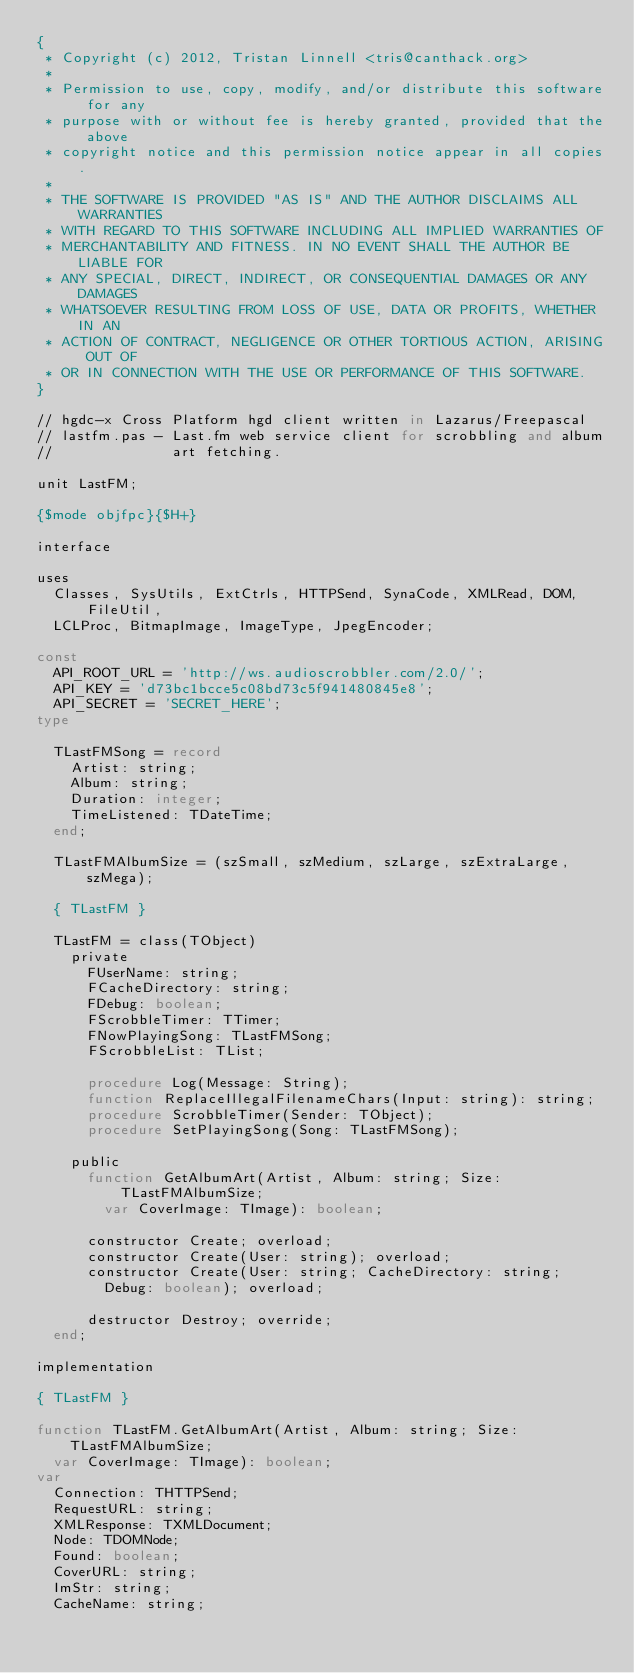<code> <loc_0><loc_0><loc_500><loc_500><_Pascal_>{
 * Copyright (c) 2012, Tristan Linnell <tris@canthack.org>
 *
 * Permission to use, copy, modify, and/or distribute this software for any
 * purpose with or without fee is hereby granted, provided that the above
 * copyright notice and this permission notice appear in all copies.
 *
 * THE SOFTWARE IS PROVIDED "AS IS" AND THE AUTHOR DISCLAIMS ALL WARRANTIES
 * WITH REGARD TO THIS SOFTWARE INCLUDING ALL IMPLIED WARRANTIES OF
 * MERCHANTABILITY AND FITNESS. IN NO EVENT SHALL THE AUTHOR BE LIABLE FOR
 * ANY SPECIAL, DIRECT, INDIRECT, OR CONSEQUENTIAL DAMAGES OR ANY DAMAGES
 * WHATSOEVER RESULTING FROM LOSS OF USE, DATA OR PROFITS, WHETHER IN AN
 * ACTION OF CONTRACT, NEGLIGENCE OR OTHER TORTIOUS ACTION, ARISING OUT OF
 * OR IN CONNECTION WITH THE USE OR PERFORMANCE OF THIS SOFTWARE.
}

// hgdc-x Cross Platform hgd client written in Lazarus/Freepascal
// lastfm.pas - Last.fm web service client for scrobbling and album
//              art fetching.

unit LastFM;

{$mode objfpc}{$H+}

interface

uses
  Classes, SysUtils, ExtCtrls, HTTPSend, SynaCode, XMLRead, DOM, FileUtil,
  LCLProc, BitmapImage, ImageType, JpegEncoder;

const
  API_ROOT_URL = 'http://ws.audioscrobbler.com/2.0/';
  API_KEY = 'd73bc1bcce5c08bd73c5f941480845e8';
  API_SECRET = 'SECRET_HERE';
type

  TLastFMSong = record
    Artist: string;
    Album: string;
    Duration: integer;
    TimeListened: TDateTime;
  end;

  TLastFMAlbumSize = (szSmall, szMedium, szLarge, szExtraLarge, szMega);

  { TLastFM }

  TLastFM = class(TObject)
    private
      FUserName: string;
      FCacheDirectory: string;
      FDebug: boolean;
      FScrobbleTimer: TTimer;
      FNowPlayingSong: TLastFMSong;
      FScrobbleList: TList;

      procedure Log(Message: String);
      function ReplaceIllegalFilenameChars(Input: string): string;
      procedure ScrobbleTimer(Sender: TObject);
      procedure SetPlayingSong(Song: TLastFMSong);

    public
      function GetAlbumArt(Artist, Album: string; Size: TLastFMAlbumSize;
        var CoverImage: TImage): boolean;

      constructor Create; overload;
      constructor Create(User: string); overload;
      constructor Create(User: string; CacheDirectory: string;
        Debug: boolean); overload;

      destructor Destroy; override;
  end;

implementation

{ TLastFM }

function TLastFM.GetAlbumArt(Artist, Album: string; Size: TLastFMAlbumSize;
  var CoverImage: TImage): boolean;
var
  Connection: THTTPSend;
  RequestURL: string;
  XMLResponse: TXMLDocument;
  Node: TDOMNode;
  Found: boolean;
  CoverURL: string;
  ImStr: string;
  CacheName: string;</code> 